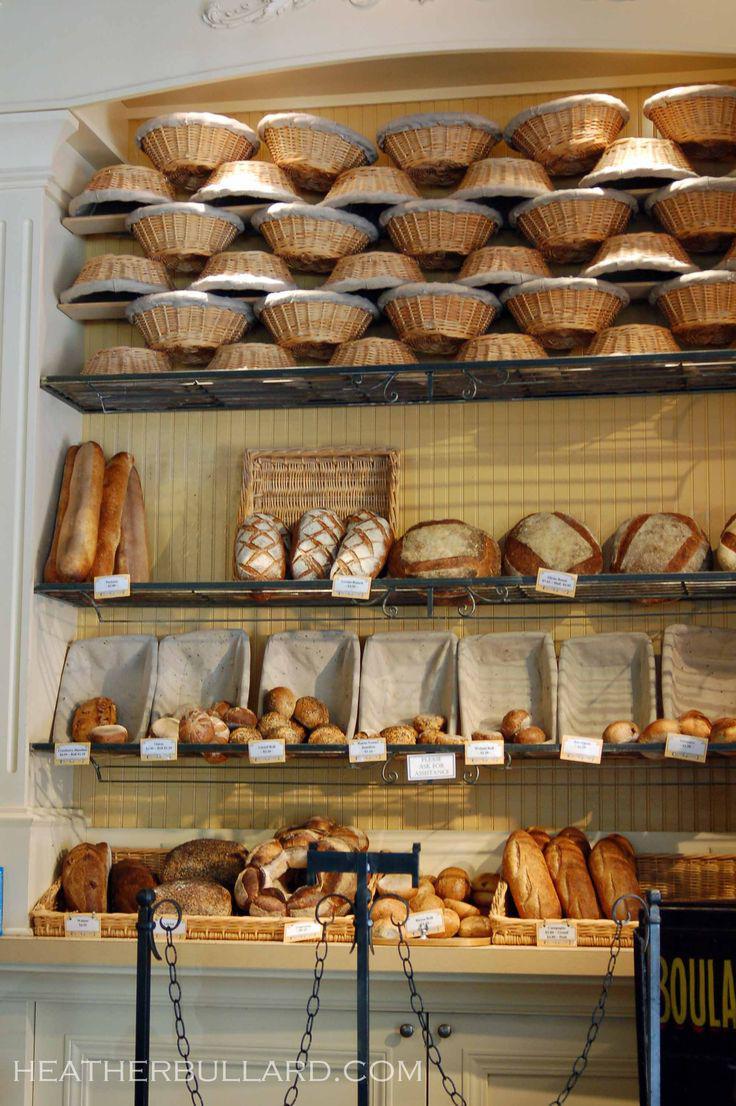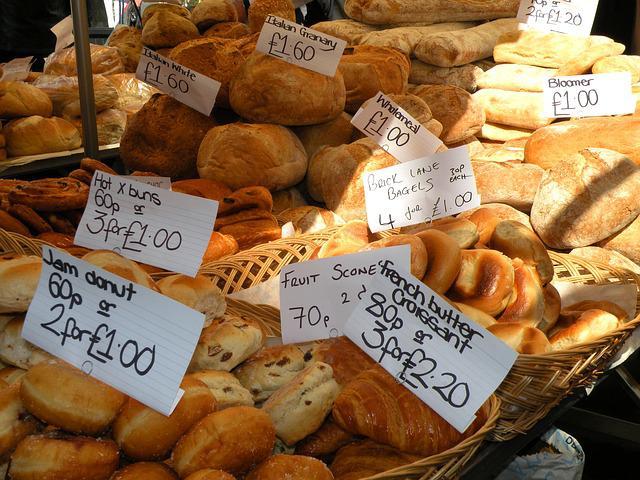The first image is the image on the left, the second image is the image on the right. Assess this claim about the two images: "Both images contain labels and prices.". Correct or not? Answer yes or no. Yes. 